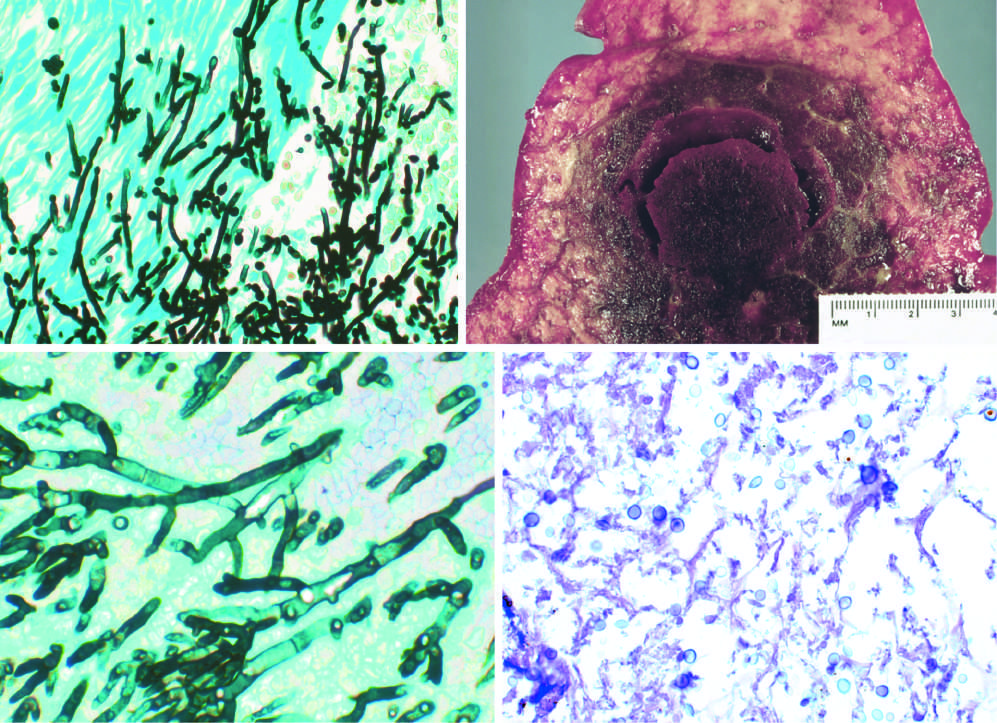re the areas of white chalky deposits somewhat variable in size?
Answer the question using a single word or phrase. No 